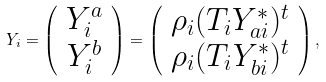<formula> <loc_0><loc_0><loc_500><loc_500>Y _ { i } = \left ( \begin{array} { c } Y _ { i } ^ { a } \\ Y _ { i } ^ { b } \end{array} \right ) = \left ( \begin{array} { c } \rho _ { i } ( T _ { i } Y ^ { * } _ { a i } ) ^ { t } \\ \rho _ { i } ( T _ { i } Y ^ { * } _ { b i } ) ^ { t } \end{array} \right ) ,</formula> 